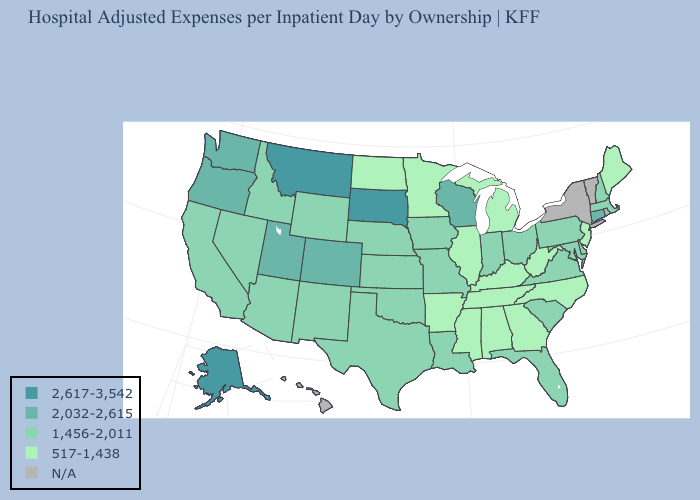Is the legend a continuous bar?
Write a very short answer. No. Among the states that border Nebraska , which have the highest value?
Short answer required. South Dakota. Name the states that have a value in the range 517-1,438?
Quick response, please. Alabama, Arkansas, Georgia, Illinois, Kentucky, Maine, Michigan, Minnesota, Mississippi, New Jersey, North Carolina, North Dakota, Tennessee, West Virginia. Name the states that have a value in the range N/A?
Write a very short answer. Hawaii, New York, Rhode Island, Vermont. Name the states that have a value in the range N/A?
Be succinct. Hawaii, New York, Rhode Island, Vermont. Name the states that have a value in the range 2,032-2,615?
Concise answer only. Colorado, Connecticut, Oregon, Utah, Washington, Wisconsin. Is the legend a continuous bar?
Give a very brief answer. No. What is the lowest value in the USA?
Be succinct. 517-1,438. Name the states that have a value in the range 2,032-2,615?
Quick response, please. Colorado, Connecticut, Oregon, Utah, Washington, Wisconsin. What is the value of Wisconsin?
Give a very brief answer. 2,032-2,615. Name the states that have a value in the range 2,032-2,615?
Write a very short answer. Colorado, Connecticut, Oregon, Utah, Washington, Wisconsin. What is the lowest value in the USA?
Give a very brief answer. 517-1,438. What is the value of Utah?
Short answer required. 2,032-2,615. Is the legend a continuous bar?
Be succinct. No. 